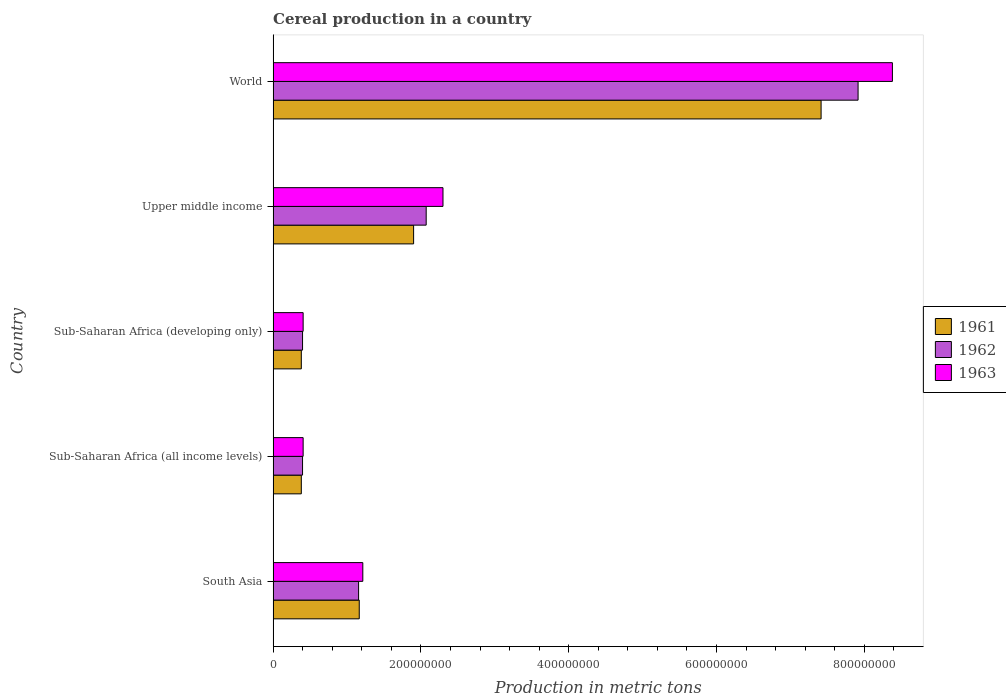How many different coloured bars are there?
Provide a succinct answer. 3. Are the number of bars per tick equal to the number of legend labels?
Make the answer very short. Yes. What is the label of the 4th group of bars from the top?
Give a very brief answer. Sub-Saharan Africa (all income levels). What is the total cereal production in 1963 in World?
Offer a very short reply. 8.38e+08. Across all countries, what is the maximum total cereal production in 1961?
Your answer should be very brief. 7.41e+08. Across all countries, what is the minimum total cereal production in 1962?
Ensure brevity in your answer.  3.98e+07. In which country was the total cereal production in 1961 minimum?
Your answer should be very brief. Sub-Saharan Africa (all income levels). What is the total total cereal production in 1961 in the graph?
Offer a terse response. 1.12e+09. What is the difference between the total cereal production in 1963 in Sub-Saharan Africa (all income levels) and that in World?
Ensure brevity in your answer.  -7.97e+08. What is the difference between the total cereal production in 1961 in Sub-Saharan Africa (developing only) and the total cereal production in 1963 in World?
Keep it short and to the point. -8.00e+08. What is the average total cereal production in 1961 per country?
Ensure brevity in your answer.  2.25e+08. What is the difference between the total cereal production in 1962 and total cereal production in 1963 in Sub-Saharan Africa (developing only)?
Your response must be concise. -7.92e+05. What is the ratio of the total cereal production in 1962 in South Asia to that in World?
Make the answer very short. 0.15. What is the difference between the highest and the second highest total cereal production in 1962?
Ensure brevity in your answer.  5.84e+08. What is the difference between the highest and the lowest total cereal production in 1963?
Keep it short and to the point. 7.97e+08. In how many countries, is the total cereal production in 1962 greater than the average total cereal production in 1962 taken over all countries?
Offer a terse response. 1. Is the sum of the total cereal production in 1962 in Sub-Saharan Africa (all income levels) and World greater than the maximum total cereal production in 1961 across all countries?
Your answer should be very brief. Yes. What does the 3rd bar from the top in South Asia represents?
Offer a terse response. 1961. How many bars are there?
Give a very brief answer. 15. Are all the bars in the graph horizontal?
Provide a succinct answer. Yes. How many countries are there in the graph?
Keep it short and to the point. 5. What is the difference between two consecutive major ticks on the X-axis?
Offer a very short reply. 2.00e+08. Does the graph contain grids?
Your answer should be very brief. No. Where does the legend appear in the graph?
Give a very brief answer. Center right. What is the title of the graph?
Offer a very short reply. Cereal production in a country. What is the label or title of the X-axis?
Provide a succinct answer. Production in metric tons. What is the label or title of the Y-axis?
Offer a very short reply. Country. What is the Production in metric tons of 1961 in South Asia?
Offer a very short reply. 1.17e+08. What is the Production in metric tons in 1962 in South Asia?
Provide a succinct answer. 1.16e+08. What is the Production in metric tons in 1963 in South Asia?
Give a very brief answer. 1.21e+08. What is the Production in metric tons in 1961 in Sub-Saharan Africa (all income levels)?
Offer a terse response. 3.81e+07. What is the Production in metric tons of 1962 in Sub-Saharan Africa (all income levels)?
Provide a succinct answer. 3.98e+07. What is the Production in metric tons of 1963 in Sub-Saharan Africa (all income levels)?
Offer a very short reply. 4.06e+07. What is the Production in metric tons of 1961 in Sub-Saharan Africa (developing only)?
Ensure brevity in your answer.  3.81e+07. What is the Production in metric tons in 1962 in Sub-Saharan Africa (developing only)?
Provide a short and direct response. 3.98e+07. What is the Production in metric tons of 1963 in Sub-Saharan Africa (developing only)?
Provide a succinct answer. 4.06e+07. What is the Production in metric tons in 1961 in Upper middle income?
Provide a short and direct response. 1.90e+08. What is the Production in metric tons of 1962 in Upper middle income?
Offer a very short reply. 2.07e+08. What is the Production in metric tons in 1963 in Upper middle income?
Your response must be concise. 2.30e+08. What is the Production in metric tons of 1961 in World?
Give a very brief answer. 7.41e+08. What is the Production in metric tons of 1962 in World?
Provide a short and direct response. 7.92e+08. What is the Production in metric tons of 1963 in World?
Your response must be concise. 8.38e+08. Across all countries, what is the maximum Production in metric tons of 1961?
Offer a terse response. 7.41e+08. Across all countries, what is the maximum Production in metric tons of 1962?
Offer a terse response. 7.92e+08. Across all countries, what is the maximum Production in metric tons in 1963?
Your response must be concise. 8.38e+08. Across all countries, what is the minimum Production in metric tons in 1961?
Your answer should be compact. 3.81e+07. Across all countries, what is the minimum Production in metric tons of 1962?
Provide a short and direct response. 3.98e+07. Across all countries, what is the minimum Production in metric tons in 1963?
Ensure brevity in your answer.  4.06e+07. What is the total Production in metric tons of 1961 in the graph?
Your answer should be very brief. 1.12e+09. What is the total Production in metric tons of 1962 in the graph?
Make the answer very short. 1.19e+09. What is the total Production in metric tons in 1963 in the graph?
Provide a short and direct response. 1.27e+09. What is the difference between the Production in metric tons of 1961 in South Asia and that in Sub-Saharan Africa (all income levels)?
Your response must be concise. 7.84e+07. What is the difference between the Production in metric tons of 1962 in South Asia and that in Sub-Saharan Africa (all income levels)?
Your answer should be very brief. 7.58e+07. What is the difference between the Production in metric tons of 1963 in South Asia and that in Sub-Saharan Africa (all income levels)?
Ensure brevity in your answer.  8.08e+07. What is the difference between the Production in metric tons in 1961 in South Asia and that in Sub-Saharan Africa (developing only)?
Your response must be concise. 7.84e+07. What is the difference between the Production in metric tons of 1962 in South Asia and that in Sub-Saharan Africa (developing only)?
Make the answer very short. 7.58e+07. What is the difference between the Production in metric tons in 1963 in South Asia and that in Sub-Saharan Africa (developing only)?
Make the answer very short. 8.08e+07. What is the difference between the Production in metric tons in 1961 in South Asia and that in Upper middle income?
Make the answer very short. -7.36e+07. What is the difference between the Production in metric tons in 1962 in South Asia and that in Upper middle income?
Make the answer very short. -9.15e+07. What is the difference between the Production in metric tons in 1963 in South Asia and that in Upper middle income?
Give a very brief answer. -1.08e+08. What is the difference between the Production in metric tons of 1961 in South Asia and that in World?
Offer a terse response. -6.25e+08. What is the difference between the Production in metric tons in 1962 in South Asia and that in World?
Give a very brief answer. -6.76e+08. What is the difference between the Production in metric tons in 1963 in South Asia and that in World?
Ensure brevity in your answer.  -7.17e+08. What is the difference between the Production in metric tons in 1961 in Sub-Saharan Africa (all income levels) and that in Sub-Saharan Africa (developing only)?
Offer a very short reply. 0. What is the difference between the Production in metric tons of 1961 in Sub-Saharan Africa (all income levels) and that in Upper middle income?
Your response must be concise. -1.52e+08. What is the difference between the Production in metric tons in 1962 in Sub-Saharan Africa (all income levels) and that in Upper middle income?
Keep it short and to the point. -1.67e+08. What is the difference between the Production in metric tons of 1963 in Sub-Saharan Africa (all income levels) and that in Upper middle income?
Ensure brevity in your answer.  -1.89e+08. What is the difference between the Production in metric tons of 1961 in Sub-Saharan Africa (all income levels) and that in World?
Keep it short and to the point. -7.03e+08. What is the difference between the Production in metric tons in 1962 in Sub-Saharan Africa (all income levels) and that in World?
Your response must be concise. -7.52e+08. What is the difference between the Production in metric tons of 1963 in Sub-Saharan Africa (all income levels) and that in World?
Provide a short and direct response. -7.97e+08. What is the difference between the Production in metric tons of 1961 in Sub-Saharan Africa (developing only) and that in Upper middle income?
Provide a short and direct response. -1.52e+08. What is the difference between the Production in metric tons of 1962 in Sub-Saharan Africa (developing only) and that in Upper middle income?
Keep it short and to the point. -1.67e+08. What is the difference between the Production in metric tons of 1963 in Sub-Saharan Africa (developing only) and that in Upper middle income?
Offer a very short reply. -1.89e+08. What is the difference between the Production in metric tons of 1961 in Sub-Saharan Africa (developing only) and that in World?
Make the answer very short. -7.03e+08. What is the difference between the Production in metric tons in 1962 in Sub-Saharan Africa (developing only) and that in World?
Your answer should be very brief. -7.52e+08. What is the difference between the Production in metric tons of 1963 in Sub-Saharan Africa (developing only) and that in World?
Provide a succinct answer. -7.97e+08. What is the difference between the Production in metric tons of 1961 in Upper middle income and that in World?
Make the answer very short. -5.51e+08. What is the difference between the Production in metric tons in 1962 in Upper middle income and that in World?
Offer a terse response. -5.84e+08. What is the difference between the Production in metric tons of 1963 in Upper middle income and that in World?
Your response must be concise. -6.08e+08. What is the difference between the Production in metric tons of 1961 in South Asia and the Production in metric tons of 1962 in Sub-Saharan Africa (all income levels)?
Your answer should be compact. 7.67e+07. What is the difference between the Production in metric tons in 1961 in South Asia and the Production in metric tons in 1963 in Sub-Saharan Africa (all income levels)?
Your response must be concise. 7.59e+07. What is the difference between the Production in metric tons in 1962 in South Asia and the Production in metric tons in 1963 in Sub-Saharan Africa (all income levels)?
Your answer should be very brief. 7.50e+07. What is the difference between the Production in metric tons of 1961 in South Asia and the Production in metric tons of 1962 in Sub-Saharan Africa (developing only)?
Offer a terse response. 7.67e+07. What is the difference between the Production in metric tons of 1961 in South Asia and the Production in metric tons of 1963 in Sub-Saharan Africa (developing only)?
Keep it short and to the point. 7.59e+07. What is the difference between the Production in metric tons of 1962 in South Asia and the Production in metric tons of 1963 in Sub-Saharan Africa (developing only)?
Your answer should be very brief. 7.50e+07. What is the difference between the Production in metric tons of 1961 in South Asia and the Production in metric tons of 1962 in Upper middle income?
Keep it short and to the point. -9.06e+07. What is the difference between the Production in metric tons of 1961 in South Asia and the Production in metric tons of 1963 in Upper middle income?
Provide a succinct answer. -1.13e+08. What is the difference between the Production in metric tons of 1962 in South Asia and the Production in metric tons of 1963 in Upper middle income?
Ensure brevity in your answer.  -1.14e+08. What is the difference between the Production in metric tons in 1961 in South Asia and the Production in metric tons in 1962 in World?
Ensure brevity in your answer.  -6.75e+08. What is the difference between the Production in metric tons of 1961 in South Asia and the Production in metric tons of 1963 in World?
Your answer should be compact. -7.21e+08. What is the difference between the Production in metric tons in 1962 in South Asia and the Production in metric tons in 1963 in World?
Your response must be concise. -7.22e+08. What is the difference between the Production in metric tons in 1961 in Sub-Saharan Africa (all income levels) and the Production in metric tons in 1962 in Sub-Saharan Africa (developing only)?
Offer a very short reply. -1.67e+06. What is the difference between the Production in metric tons of 1961 in Sub-Saharan Africa (all income levels) and the Production in metric tons of 1963 in Sub-Saharan Africa (developing only)?
Offer a very short reply. -2.46e+06. What is the difference between the Production in metric tons in 1962 in Sub-Saharan Africa (all income levels) and the Production in metric tons in 1963 in Sub-Saharan Africa (developing only)?
Offer a very short reply. -7.92e+05. What is the difference between the Production in metric tons of 1961 in Sub-Saharan Africa (all income levels) and the Production in metric tons of 1962 in Upper middle income?
Provide a succinct answer. -1.69e+08. What is the difference between the Production in metric tons of 1961 in Sub-Saharan Africa (all income levels) and the Production in metric tons of 1963 in Upper middle income?
Your answer should be very brief. -1.92e+08. What is the difference between the Production in metric tons of 1962 in Sub-Saharan Africa (all income levels) and the Production in metric tons of 1963 in Upper middle income?
Keep it short and to the point. -1.90e+08. What is the difference between the Production in metric tons of 1961 in Sub-Saharan Africa (all income levels) and the Production in metric tons of 1962 in World?
Provide a succinct answer. -7.53e+08. What is the difference between the Production in metric tons of 1961 in Sub-Saharan Africa (all income levels) and the Production in metric tons of 1963 in World?
Ensure brevity in your answer.  -8.00e+08. What is the difference between the Production in metric tons of 1962 in Sub-Saharan Africa (all income levels) and the Production in metric tons of 1963 in World?
Keep it short and to the point. -7.98e+08. What is the difference between the Production in metric tons in 1961 in Sub-Saharan Africa (developing only) and the Production in metric tons in 1962 in Upper middle income?
Give a very brief answer. -1.69e+08. What is the difference between the Production in metric tons of 1961 in Sub-Saharan Africa (developing only) and the Production in metric tons of 1963 in Upper middle income?
Your answer should be compact. -1.92e+08. What is the difference between the Production in metric tons of 1962 in Sub-Saharan Africa (developing only) and the Production in metric tons of 1963 in Upper middle income?
Offer a terse response. -1.90e+08. What is the difference between the Production in metric tons of 1961 in Sub-Saharan Africa (developing only) and the Production in metric tons of 1962 in World?
Provide a short and direct response. -7.53e+08. What is the difference between the Production in metric tons of 1961 in Sub-Saharan Africa (developing only) and the Production in metric tons of 1963 in World?
Provide a short and direct response. -8.00e+08. What is the difference between the Production in metric tons in 1962 in Sub-Saharan Africa (developing only) and the Production in metric tons in 1963 in World?
Keep it short and to the point. -7.98e+08. What is the difference between the Production in metric tons in 1961 in Upper middle income and the Production in metric tons in 1962 in World?
Offer a terse response. -6.01e+08. What is the difference between the Production in metric tons in 1961 in Upper middle income and the Production in metric tons in 1963 in World?
Your answer should be compact. -6.48e+08. What is the difference between the Production in metric tons of 1962 in Upper middle income and the Production in metric tons of 1963 in World?
Offer a very short reply. -6.31e+08. What is the average Production in metric tons of 1961 per country?
Offer a terse response. 2.25e+08. What is the average Production in metric tons in 1962 per country?
Provide a short and direct response. 2.39e+08. What is the average Production in metric tons in 1963 per country?
Your answer should be very brief. 2.54e+08. What is the difference between the Production in metric tons of 1961 and Production in metric tons of 1962 in South Asia?
Provide a succinct answer. 8.99e+05. What is the difference between the Production in metric tons of 1961 and Production in metric tons of 1963 in South Asia?
Provide a short and direct response. -4.82e+06. What is the difference between the Production in metric tons of 1962 and Production in metric tons of 1963 in South Asia?
Your response must be concise. -5.72e+06. What is the difference between the Production in metric tons in 1961 and Production in metric tons in 1962 in Sub-Saharan Africa (all income levels)?
Offer a terse response. -1.67e+06. What is the difference between the Production in metric tons of 1961 and Production in metric tons of 1963 in Sub-Saharan Africa (all income levels)?
Provide a succinct answer. -2.46e+06. What is the difference between the Production in metric tons in 1962 and Production in metric tons in 1963 in Sub-Saharan Africa (all income levels)?
Provide a short and direct response. -7.92e+05. What is the difference between the Production in metric tons in 1961 and Production in metric tons in 1962 in Sub-Saharan Africa (developing only)?
Provide a succinct answer. -1.67e+06. What is the difference between the Production in metric tons in 1961 and Production in metric tons in 1963 in Sub-Saharan Africa (developing only)?
Your answer should be very brief. -2.46e+06. What is the difference between the Production in metric tons of 1962 and Production in metric tons of 1963 in Sub-Saharan Africa (developing only)?
Keep it short and to the point. -7.92e+05. What is the difference between the Production in metric tons in 1961 and Production in metric tons in 1962 in Upper middle income?
Your answer should be compact. -1.70e+07. What is the difference between the Production in metric tons in 1961 and Production in metric tons in 1963 in Upper middle income?
Provide a short and direct response. -3.98e+07. What is the difference between the Production in metric tons of 1962 and Production in metric tons of 1963 in Upper middle income?
Give a very brief answer. -2.27e+07. What is the difference between the Production in metric tons in 1961 and Production in metric tons in 1962 in World?
Provide a succinct answer. -5.00e+07. What is the difference between the Production in metric tons in 1961 and Production in metric tons in 1963 in World?
Give a very brief answer. -9.65e+07. What is the difference between the Production in metric tons of 1962 and Production in metric tons of 1963 in World?
Give a very brief answer. -4.64e+07. What is the ratio of the Production in metric tons of 1961 in South Asia to that in Sub-Saharan Africa (all income levels)?
Keep it short and to the point. 3.06. What is the ratio of the Production in metric tons of 1962 in South Asia to that in Sub-Saharan Africa (all income levels)?
Provide a short and direct response. 2.9. What is the ratio of the Production in metric tons in 1963 in South Asia to that in Sub-Saharan Africa (all income levels)?
Ensure brevity in your answer.  2.99. What is the ratio of the Production in metric tons of 1961 in South Asia to that in Sub-Saharan Africa (developing only)?
Provide a short and direct response. 3.06. What is the ratio of the Production in metric tons in 1962 in South Asia to that in Sub-Saharan Africa (developing only)?
Offer a very short reply. 2.9. What is the ratio of the Production in metric tons in 1963 in South Asia to that in Sub-Saharan Africa (developing only)?
Your response must be concise. 2.99. What is the ratio of the Production in metric tons in 1961 in South Asia to that in Upper middle income?
Your response must be concise. 0.61. What is the ratio of the Production in metric tons of 1962 in South Asia to that in Upper middle income?
Your answer should be very brief. 0.56. What is the ratio of the Production in metric tons of 1963 in South Asia to that in Upper middle income?
Make the answer very short. 0.53. What is the ratio of the Production in metric tons in 1961 in South Asia to that in World?
Make the answer very short. 0.16. What is the ratio of the Production in metric tons in 1962 in South Asia to that in World?
Your response must be concise. 0.15. What is the ratio of the Production in metric tons of 1963 in South Asia to that in World?
Your response must be concise. 0.14. What is the ratio of the Production in metric tons in 1961 in Sub-Saharan Africa (all income levels) to that in Sub-Saharan Africa (developing only)?
Provide a short and direct response. 1. What is the ratio of the Production in metric tons of 1962 in Sub-Saharan Africa (all income levels) to that in Sub-Saharan Africa (developing only)?
Keep it short and to the point. 1. What is the ratio of the Production in metric tons in 1963 in Sub-Saharan Africa (all income levels) to that in Sub-Saharan Africa (developing only)?
Your response must be concise. 1. What is the ratio of the Production in metric tons in 1961 in Sub-Saharan Africa (all income levels) to that in Upper middle income?
Your answer should be very brief. 0.2. What is the ratio of the Production in metric tons in 1962 in Sub-Saharan Africa (all income levels) to that in Upper middle income?
Your response must be concise. 0.19. What is the ratio of the Production in metric tons of 1963 in Sub-Saharan Africa (all income levels) to that in Upper middle income?
Offer a very short reply. 0.18. What is the ratio of the Production in metric tons in 1961 in Sub-Saharan Africa (all income levels) to that in World?
Your response must be concise. 0.05. What is the ratio of the Production in metric tons of 1962 in Sub-Saharan Africa (all income levels) to that in World?
Give a very brief answer. 0.05. What is the ratio of the Production in metric tons in 1963 in Sub-Saharan Africa (all income levels) to that in World?
Offer a very short reply. 0.05. What is the ratio of the Production in metric tons of 1961 in Sub-Saharan Africa (developing only) to that in Upper middle income?
Your answer should be very brief. 0.2. What is the ratio of the Production in metric tons of 1962 in Sub-Saharan Africa (developing only) to that in Upper middle income?
Give a very brief answer. 0.19. What is the ratio of the Production in metric tons in 1963 in Sub-Saharan Africa (developing only) to that in Upper middle income?
Provide a succinct answer. 0.18. What is the ratio of the Production in metric tons of 1961 in Sub-Saharan Africa (developing only) to that in World?
Provide a short and direct response. 0.05. What is the ratio of the Production in metric tons in 1962 in Sub-Saharan Africa (developing only) to that in World?
Give a very brief answer. 0.05. What is the ratio of the Production in metric tons in 1963 in Sub-Saharan Africa (developing only) to that in World?
Keep it short and to the point. 0.05. What is the ratio of the Production in metric tons of 1961 in Upper middle income to that in World?
Provide a succinct answer. 0.26. What is the ratio of the Production in metric tons of 1962 in Upper middle income to that in World?
Give a very brief answer. 0.26. What is the ratio of the Production in metric tons in 1963 in Upper middle income to that in World?
Offer a terse response. 0.27. What is the difference between the highest and the second highest Production in metric tons in 1961?
Provide a short and direct response. 5.51e+08. What is the difference between the highest and the second highest Production in metric tons of 1962?
Your answer should be compact. 5.84e+08. What is the difference between the highest and the second highest Production in metric tons in 1963?
Provide a succinct answer. 6.08e+08. What is the difference between the highest and the lowest Production in metric tons in 1961?
Make the answer very short. 7.03e+08. What is the difference between the highest and the lowest Production in metric tons of 1962?
Ensure brevity in your answer.  7.52e+08. What is the difference between the highest and the lowest Production in metric tons of 1963?
Make the answer very short. 7.97e+08. 